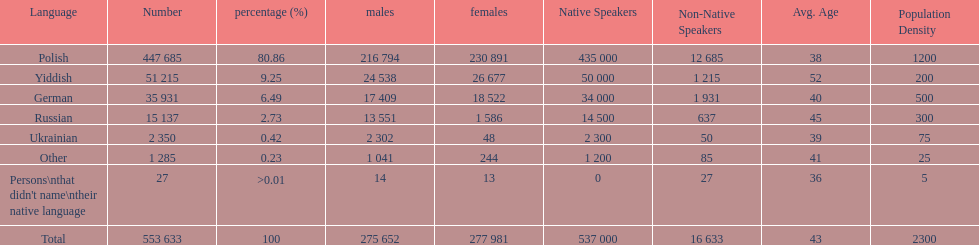What were the languages in plock governorate? Polish, Yiddish, German, Russian, Ukrainian, Other. Which language has a value of .42? Ukrainian. 